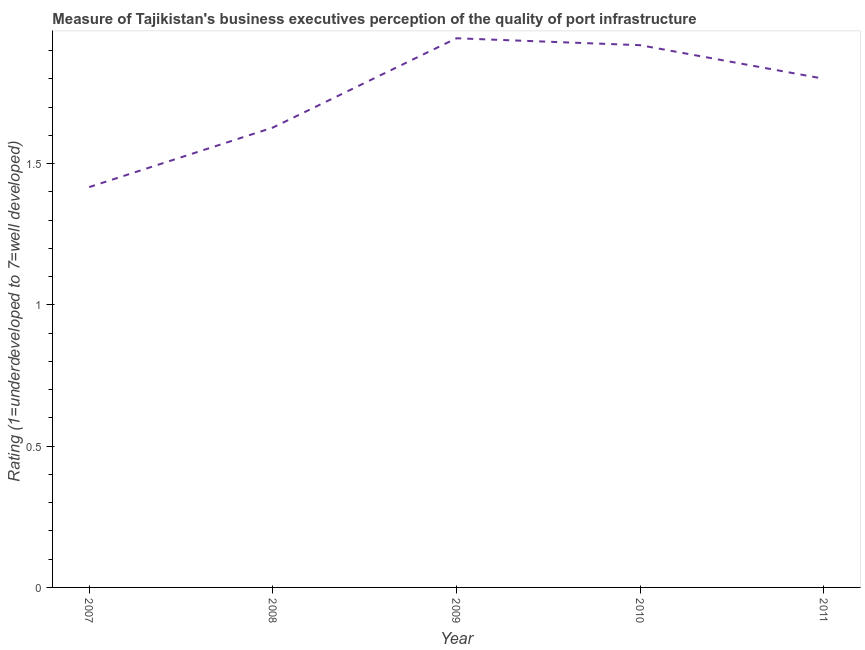Across all years, what is the maximum rating measuring quality of port infrastructure?
Offer a terse response. 1.94. Across all years, what is the minimum rating measuring quality of port infrastructure?
Your response must be concise. 1.42. In which year was the rating measuring quality of port infrastructure maximum?
Your answer should be very brief. 2009. What is the sum of the rating measuring quality of port infrastructure?
Offer a very short reply. 8.71. What is the difference between the rating measuring quality of port infrastructure in 2007 and 2010?
Make the answer very short. -0.5. What is the average rating measuring quality of port infrastructure per year?
Your answer should be compact. 1.74. What is the median rating measuring quality of port infrastructure?
Offer a very short reply. 1.8. What is the ratio of the rating measuring quality of port infrastructure in 2009 to that in 2011?
Provide a succinct answer. 1.08. Is the rating measuring quality of port infrastructure in 2007 less than that in 2009?
Make the answer very short. Yes. What is the difference between the highest and the second highest rating measuring quality of port infrastructure?
Provide a short and direct response. 0.02. What is the difference between the highest and the lowest rating measuring quality of port infrastructure?
Keep it short and to the point. 0.53. In how many years, is the rating measuring quality of port infrastructure greater than the average rating measuring quality of port infrastructure taken over all years?
Give a very brief answer. 3. Does the rating measuring quality of port infrastructure monotonically increase over the years?
Your answer should be very brief. No. How many lines are there?
Keep it short and to the point. 1. What is the difference between two consecutive major ticks on the Y-axis?
Your response must be concise. 0.5. Are the values on the major ticks of Y-axis written in scientific E-notation?
Offer a terse response. No. Does the graph contain any zero values?
Your answer should be very brief. No. What is the title of the graph?
Your response must be concise. Measure of Tajikistan's business executives perception of the quality of port infrastructure. What is the label or title of the X-axis?
Provide a short and direct response. Year. What is the label or title of the Y-axis?
Offer a very short reply. Rating (1=underdeveloped to 7=well developed) . What is the Rating (1=underdeveloped to 7=well developed)  in 2007?
Offer a very short reply. 1.42. What is the Rating (1=underdeveloped to 7=well developed)  of 2008?
Your response must be concise. 1.63. What is the Rating (1=underdeveloped to 7=well developed)  of 2009?
Make the answer very short. 1.94. What is the Rating (1=underdeveloped to 7=well developed)  in 2010?
Keep it short and to the point. 1.92. What is the difference between the Rating (1=underdeveloped to 7=well developed)  in 2007 and 2008?
Your answer should be compact. -0.21. What is the difference between the Rating (1=underdeveloped to 7=well developed)  in 2007 and 2009?
Make the answer very short. -0.53. What is the difference between the Rating (1=underdeveloped to 7=well developed)  in 2007 and 2010?
Keep it short and to the point. -0.5. What is the difference between the Rating (1=underdeveloped to 7=well developed)  in 2007 and 2011?
Provide a succinct answer. -0.38. What is the difference between the Rating (1=underdeveloped to 7=well developed)  in 2008 and 2009?
Make the answer very short. -0.32. What is the difference between the Rating (1=underdeveloped to 7=well developed)  in 2008 and 2010?
Give a very brief answer. -0.29. What is the difference between the Rating (1=underdeveloped to 7=well developed)  in 2008 and 2011?
Offer a very short reply. -0.17. What is the difference between the Rating (1=underdeveloped to 7=well developed)  in 2009 and 2010?
Give a very brief answer. 0.02. What is the difference between the Rating (1=underdeveloped to 7=well developed)  in 2009 and 2011?
Offer a terse response. 0.14. What is the difference between the Rating (1=underdeveloped to 7=well developed)  in 2010 and 2011?
Your response must be concise. 0.12. What is the ratio of the Rating (1=underdeveloped to 7=well developed)  in 2007 to that in 2008?
Keep it short and to the point. 0.87. What is the ratio of the Rating (1=underdeveloped to 7=well developed)  in 2007 to that in 2009?
Provide a succinct answer. 0.73. What is the ratio of the Rating (1=underdeveloped to 7=well developed)  in 2007 to that in 2010?
Provide a short and direct response. 0.74. What is the ratio of the Rating (1=underdeveloped to 7=well developed)  in 2007 to that in 2011?
Keep it short and to the point. 0.79. What is the ratio of the Rating (1=underdeveloped to 7=well developed)  in 2008 to that in 2009?
Provide a succinct answer. 0.84. What is the ratio of the Rating (1=underdeveloped to 7=well developed)  in 2008 to that in 2010?
Offer a very short reply. 0.85. What is the ratio of the Rating (1=underdeveloped to 7=well developed)  in 2008 to that in 2011?
Provide a succinct answer. 0.9. What is the ratio of the Rating (1=underdeveloped to 7=well developed)  in 2009 to that in 2010?
Your answer should be compact. 1.01. What is the ratio of the Rating (1=underdeveloped to 7=well developed)  in 2009 to that in 2011?
Your response must be concise. 1.08. What is the ratio of the Rating (1=underdeveloped to 7=well developed)  in 2010 to that in 2011?
Ensure brevity in your answer.  1.07. 